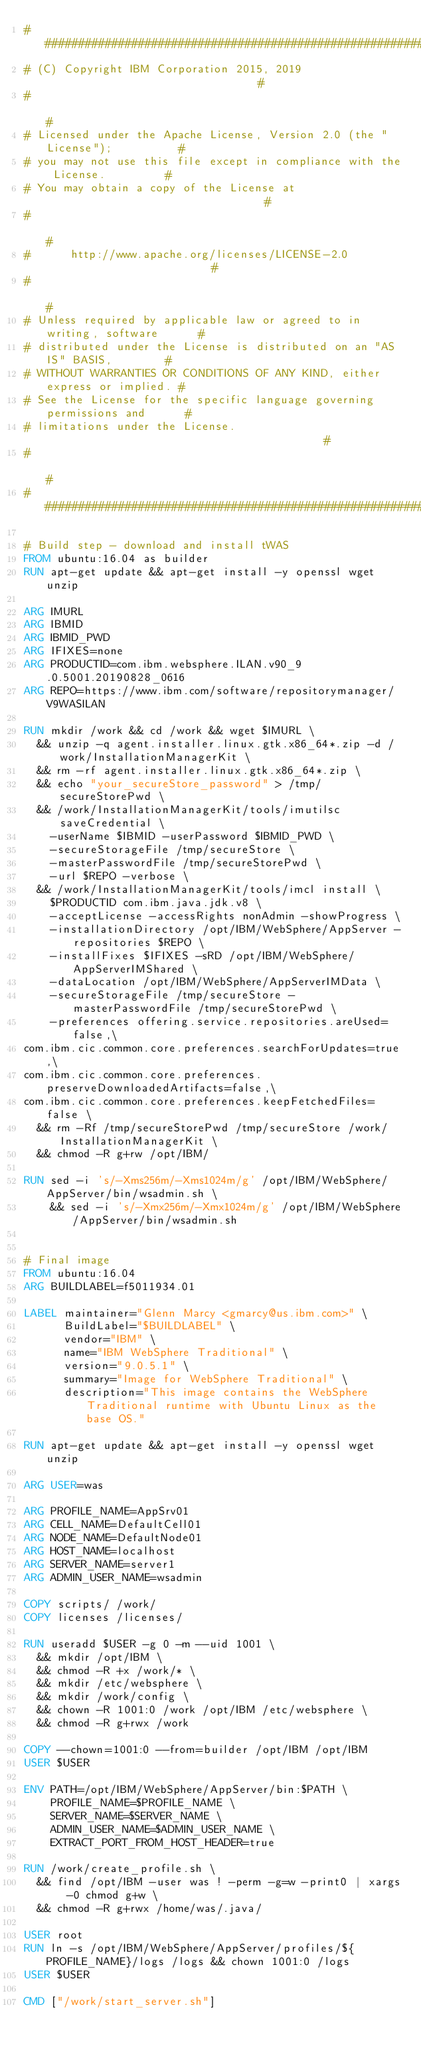Convert code to text. <code><loc_0><loc_0><loc_500><loc_500><_Dockerfile_>############################################################################
# (C) Copyright IBM Corporation 2015, 2019                                 #
#                                                                          #
# Licensed under the Apache License, Version 2.0 (the "License");          #
# you may not use this file except in compliance with the License.         #
# You may obtain a copy of the License at                                  #
#                                                                          #
#      http://www.apache.org/licenses/LICENSE-2.0                          #
#                                                                          #
# Unless required by applicable law or agreed to in writing, software      #
# distributed under the License is distributed on an "AS IS" BASIS,        #
# WITHOUT WARRANTIES OR CONDITIONS OF ANY KIND, either express or implied. #
# See the License for the specific language governing permissions and      #
# limitations under the License.                                           #
#                                                                          #
############################################################################

# Build step - download and install tWAS
FROM ubuntu:16.04 as builder
RUN apt-get update && apt-get install -y openssl wget unzip

ARG IMURL
ARG IBMID
ARG IBMID_PWD
ARG IFIXES=none
ARG PRODUCTID=com.ibm.websphere.ILAN.v90_9.0.5001.20190828_0616
ARG REPO=https://www.ibm.com/software/repositorymanager/V9WASILAN

RUN mkdir /work && cd /work && wget $IMURL \
  && unzip -q agent.installer.linux.gtk.x86_64*.zip -d /work/InstallationManagerKit \
  && rm -rf agent.installer.linux.gtk.x86_64*.zip \
  && echo "your_secureStore_password" > /tmp/secureStorePwd \
  && /work/InstallationManagerKit/tools/imutilsc saveCredential \
    -userName $IBMID -userPassword $IBMID_PWD \
    -secureStorageFile /tmp/secureStore \
    -masterPasswordFile /tmp/secureStorePwd \
    -url $REPO -verbose \
  && /work/InstallationManagerKit/tools/imcl install \
    $PRODUCTID com.ibm.java.jdk.v8 \
    -acceptLicense -accessRights nonAdmin -showProgress \
    -installationDirectory /opt/IBM/WebSphere/AppServer -repositories $REPO \
    -installFixes $IFIXES -sRD /opt/IBM/WebSphere/AppServerIMShared \
    -dataLocation /opt/IBM/WebSphere/AppServerIMData \
    -secureStorageFile /tmp/secureStore -masterPasswordFile /tmp/secureStorePwd \
    -preferences offering.service.repositories.areUsed=false,\
com.ibm.cic.common.core.preferences.searchForUpdates=true,\
com.ibm.cic.common.core.preferences.preserveDownloadedArtifacts=false,\
com.ibm.cic.common.core.preferences.keepFetchedFiles=false \
  && rm -Rf /tmp/secureStorePwd /tmp/secureStore /work/InstallationManagerKit \
  && chmod -R g+rw /opt/IBM/

RUN sed -i 's/-Xms256m/-Xms1024m/g' /opt/IBM/WebSphere/AppServer/bin/wsadmin.sh \
    && sed -i 's/-Xmx256m/-Xmx1024m/g' /opt/IBM/WebSphere/AppServer/bin/wsadmin.sh


# Final image
FROM ubuntu:16.04
ARG BUILDLABEL=f5011934.01

LABEL maintainer="Glenn Marcy <gmarcy@us.ibm.com>" \
      BuildLabel="$BUILDLABEL" \
      vendor="IBM" \
      name="IBM WebSphere Traditional" \
      version="9.0.5.1" \
      summary="Image for WebSphere Traditional" \
      description="This image contains the WebSphere Traditional runtime with Ubuntu Linux as the base OS."

RUN apt-get update && apt-get install -y openssl wget unzip

ARG USER=was

ARG PROFILE_NAME=AppSrv01
ARG CELL_NAME=DefaultCell01
ARG NODE_NAME=DefaultNode01
ARG HOST_NAME=localhost
ARG SERVER_NAME=server1
ARG ADMIN_USER_NAME=wsadmin

COPY scripts/ /work/
COPY licenses /licenses/

RUN useradd $USER -g 0 -m --uid 1001 \
  && mkdir /opt/IBM \
  && chmod -R +x /work/* \
  && mkdir /etc/websphere \
  && mkdir /work/config \
  && chown -R 1001:0 /work /opt/IBM /etc/websphere \
  && chmod -R g+rwx /work

COPY --chown=1001:0 --from=builder /opt/IBM /opt/IBM
USER $USER

ENV PATH=/opt/IBM/WebSphere/AppServer/bin:$PATH \
    PROFILE_NAME=$PROFILE_NAME \
    SERVER_NAME=$SERVER_NAME \
    ADMIN_USER_NAME=$ADMIN_USER_NAME \
    EXTRACT_PORT_FROM_HOST_HEADER=true

RUN /work/create_profile.sh \
  && find /opt/IBM -user was ! -perm -g=w -print0 | xargs -0 chmod g+w \
  && chmod -R g+rwx /home/was/.java/

USER root
RUN ln -s /opt/IBM/WebSphere/AppServer/profiles/${PROFILE_NAME}/logs /logs && chown 1001:0 /logs
USER $USER

CMD ["/work/start_server.sh"]
</code> 